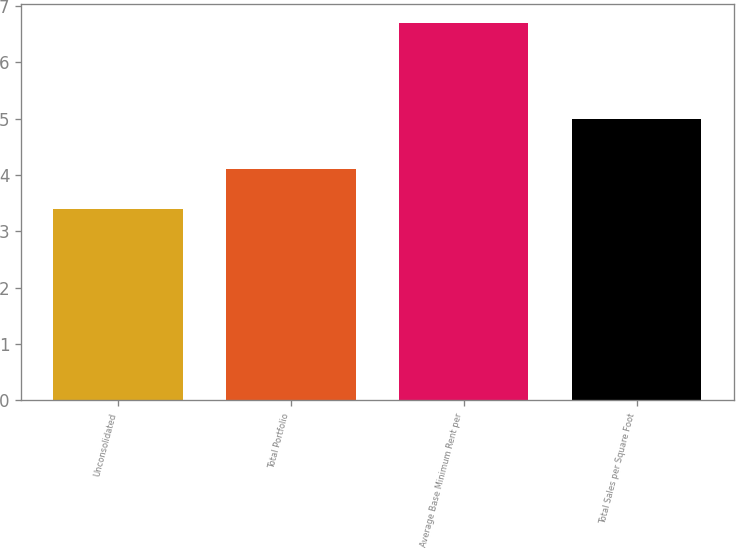Convert chart to OTSL. <chart><loc_0><loc_0><loc_500><loc_500><bar_chart><fcel>Unconsolidated<fcel>Total Portfolio<fcel>Average Base Minimum Rent per<fcel>Total Sales per Square Foot<nl><fcel>3.4<fcel>4.1<fcel>6.7<fcel>5<nl></chart> 